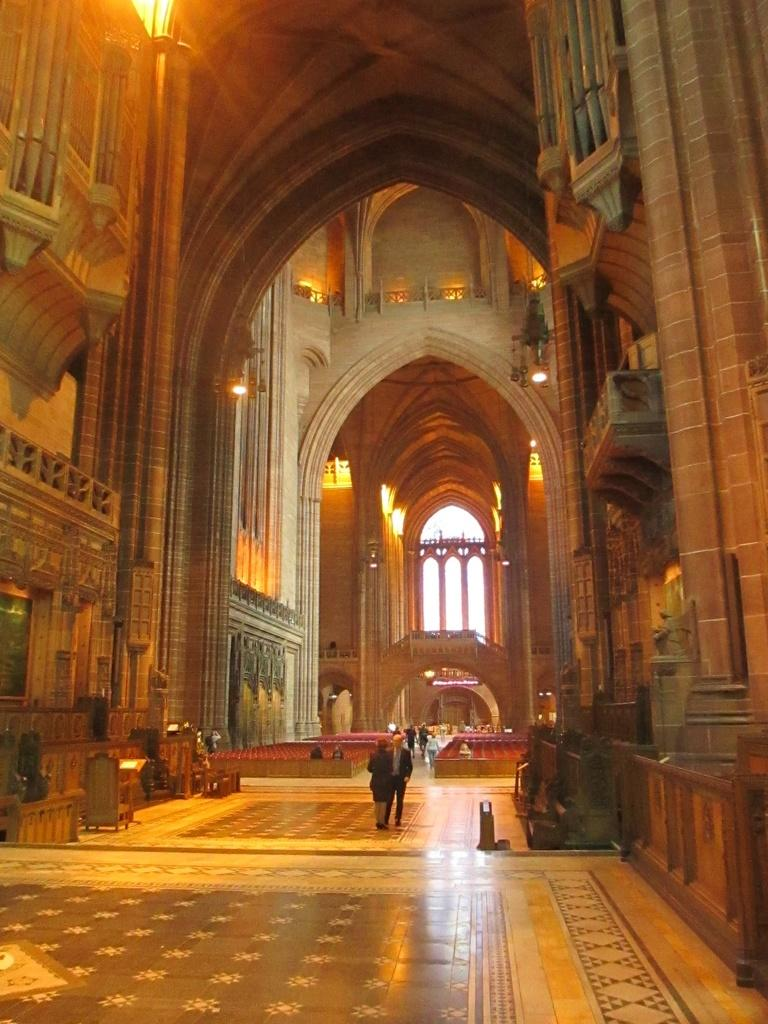What part of a building is shown in the image? The image shows the inner part of a building. Are there any people present in the image? Yes, there are people standing in the image. What can be seen in the background of the image? The sky is visible in the background of the image, and it appears to be white. Where is the sofa located in the image? There is no sofa present in the image. What part of the brain can be seen in the image? There is no brain visible in the image; it shows the inner part of a building. 